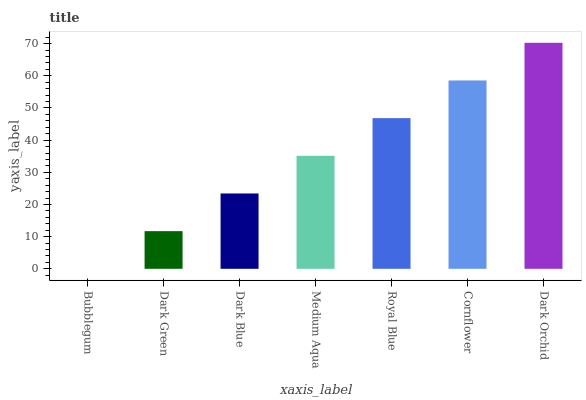Is Dark Green the minimum?
Answer yes or no. No. Is Dark Green the maximum?
Answer yes or no. No. Is Dark Green greater than Bubblegum?
Answer yes or no. Yes. Is Bubblegum less than Dark Green?
Answer yes or no. Yes. Is Bubblegum greater than Dark Green?
Answer yes or no. No. Is Dark Green less than Bubblegum?
Answer yes or no. No. Is Medium Aqua the high median?
Answer yes or no. Yes. Is Medium Aqua the low median?
Answer yes or no. Yes. Is Dark Green the high median?
Answer yes or no. No. Is Bubblegum the low median?
Answer yes or no. No. 